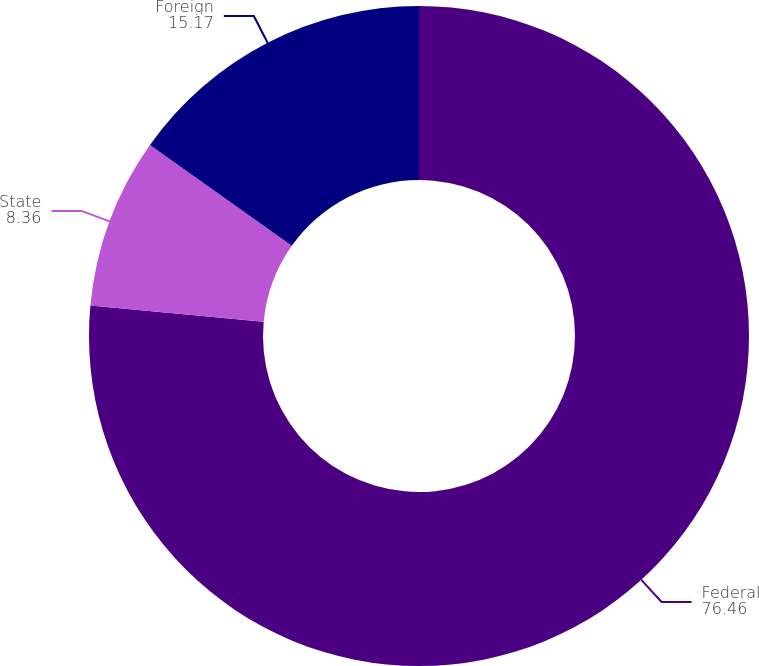Convert chart. <chart><loc_0><loc_0><loc_500><loc_500><pie_chart><fcel>Federal<fcel>State<fcel>Foreign<nl><fcel>76.46%<fcel>8.36%<fcel>15.17%<nl></chart> 